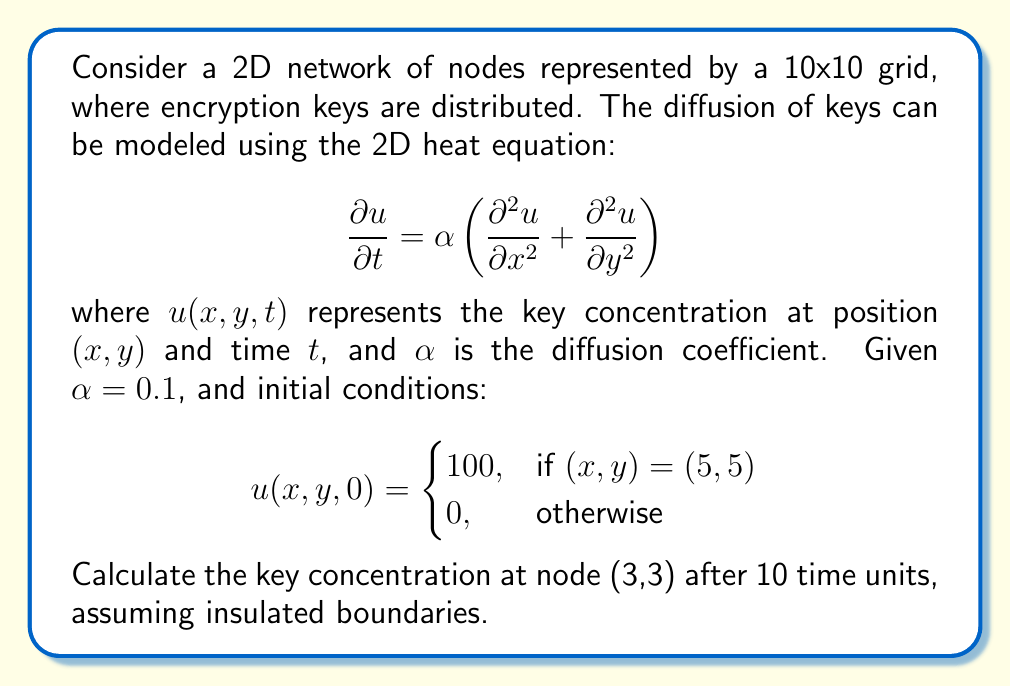Give your solution to this math problem. To solve this problem, we'll use the finite difference method to approximate the solution of the 2D heat equation:

1. Discretize the domain:
   - Spatial step: $\Delta x = \Delta y = 1$ (given 10x10 grid)
   - Time step: Let's choose $\Delta t = 0.1$ for stability

2. Use the explicit finite difference scheme:
   $$u_{i,j}^{n+1} = u_{i,j}^n + \frac{\alpha \Delta t}{(\Delta x)^2}(u_{i+1,j}^n + u_{i-1,j}^n + u_{i,j+1}^n + u_{i,j-1}^n - 4u_{i,j}^n)$$

3. Check stability condition:
   $$\frac{\alpha \Delta t}{(\Delta x)^2} \leq \frac{1}{4}$$
   $$\frac{0.1 \cdot 0.1}{1^2} = 0.01 \leq \frac{1}{4}$$ (satisfied)

4. Implement the scheme:
   - Initialize the grid with the given initial conditions
   - For each time step:
     - Update interior nodes using the finite difference equation
     - Apply insulated boundary conditions (set boundary nodes equal to their adjacent interior nodes)

5. Run the simulation for 100 time steps (10 time units / 0.1 time step)

6. Extract the value at node (3,3) after 100 time steps

The implementation of this algorithm in a programming language like Python would yield the final result.
Answer: Approximately 1.62 